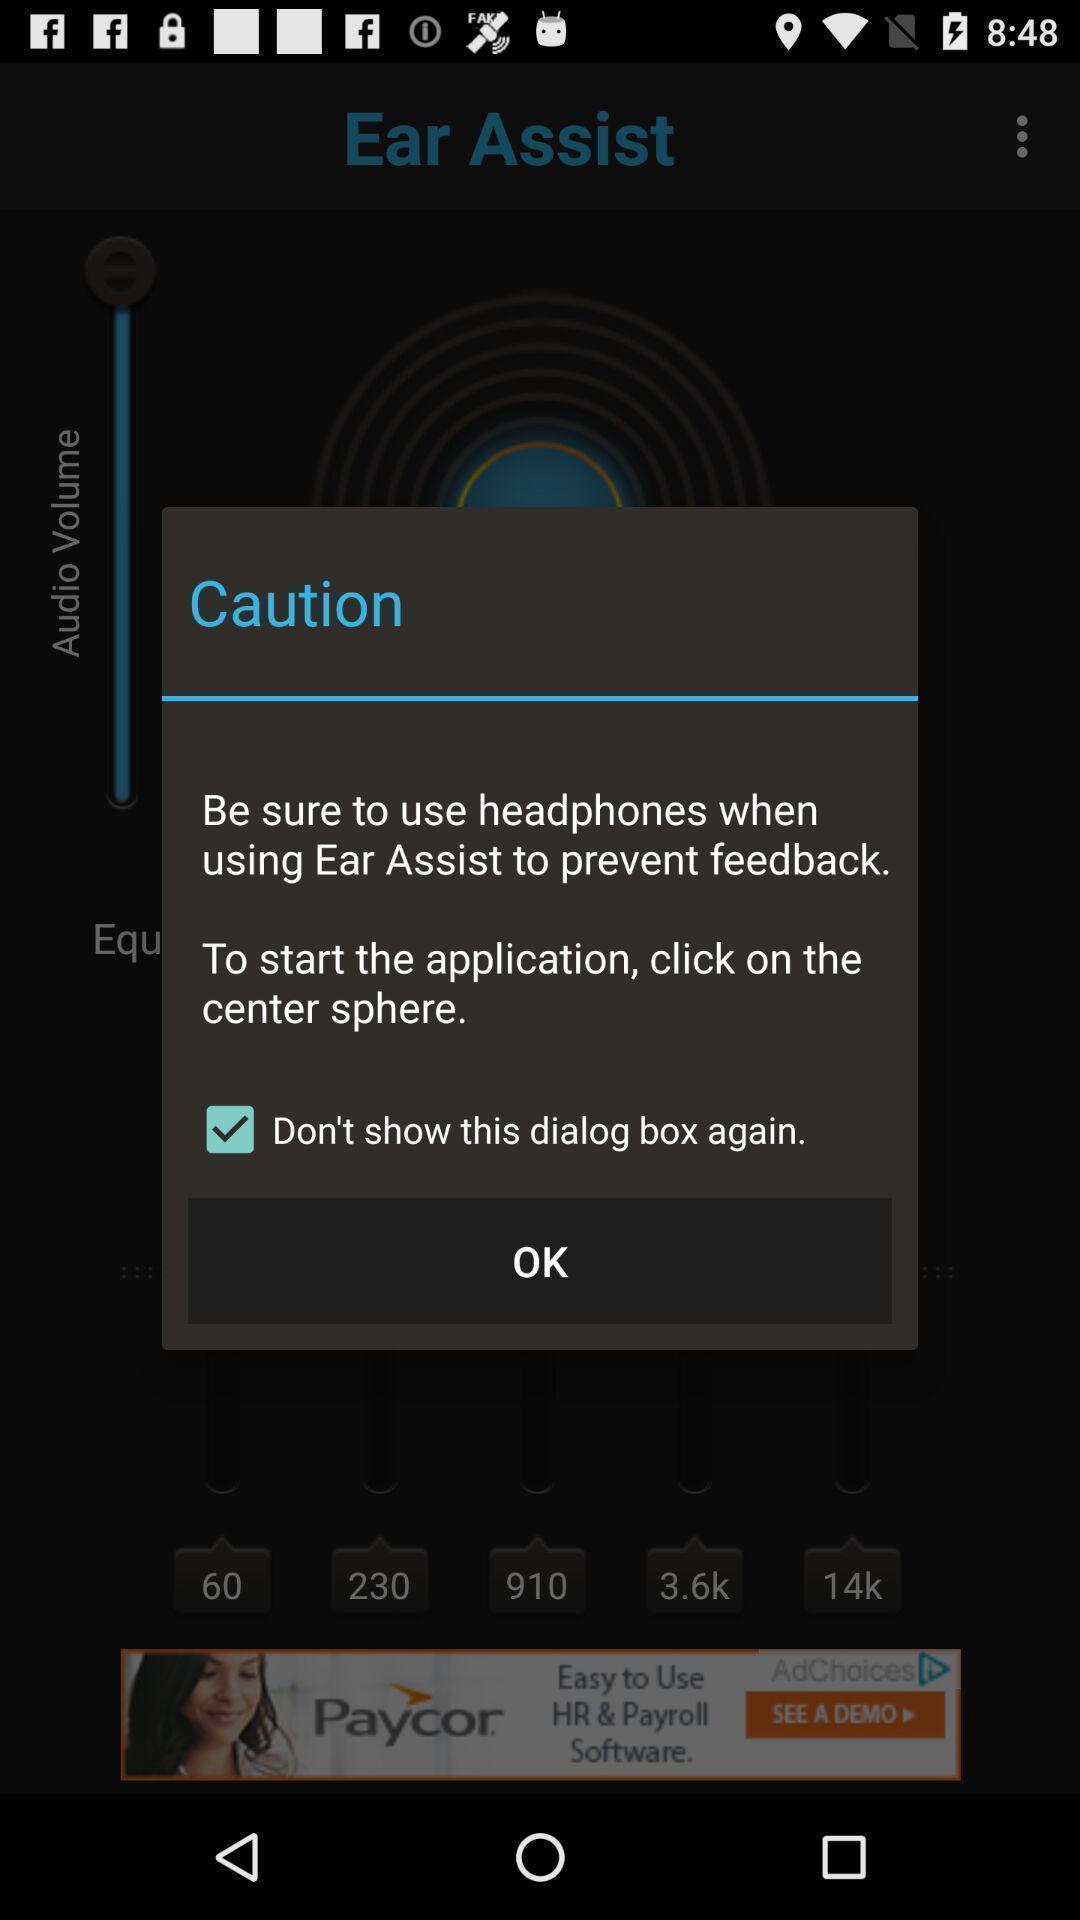Describe the key features of this screenshot. Popup of warning text to use headphones in mobile. 